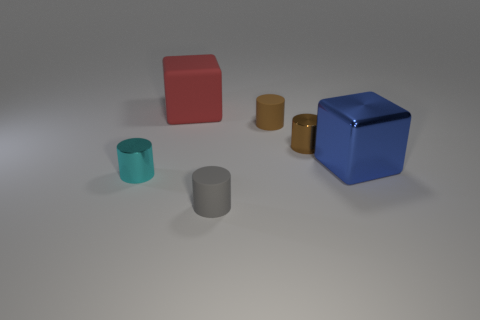Are there any brown metallic things that are in front of the rubber cylinder behind the rubber cylinder that is in front of the blue block?
Give a very brief answer. Yes. There is a cyan metallic object that is the same size as the brown matte cylinder; what is its shape?
Keep it short and to the point. Cylinder. There is another large thing that is the same shape as the red rubber thing; what color is it?
Offer a terse response. Blue. What number of things are tiny brown shiny objects or small purple metal cylinders?
Provide a short and direct response. 1. Do the large object to the left of the blue shiny block and the big blue metal thing that is to the right of the big matte block have the same shape?
Keep it short and to the point. Yes. What shape is the matte object that is in front of the shiny block?
Offer a very short reply. Cylinder. Is the number of red objects right of the shiny cube the same as the number of small cylinders that are in front of the brown rubber cylinder?
Ensure brevity in your answer.  No. How many objects are cyan metal things or small cylinders that are to the right of the rubber cube?
Your response must be concise. 4. What is the shape of the matte thing that is both to the right of the red rubber block and behind the tiny cyan metal object?
Provide a succinct answer. Cylinder. The big object behind the block that is to the right of the big red matte thing is made of what material?
Provide a short and direct response. Rubber. 